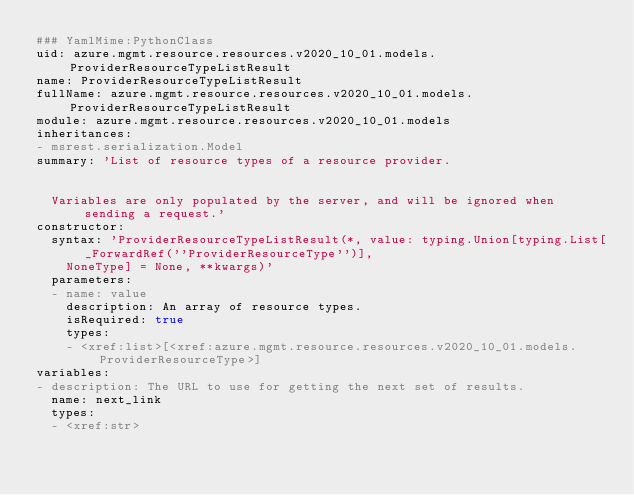<code> <loc_0><loc_0><loc_500><loc_500><_YAML_>### YamlMime:PythonClass
uid: azure.mgmt.resource.resources.v2020_10_01.models.ProviderResourceTypeListResult
name: ProviderResourceTypeListResult
fullName: azure.mgmt.resource.resources.v2020_10_01.models.ProviderResourceTypeListResult
module: azure.mgmt.resource.resources.v2020_10_01.models
inheritances:
- msrest.serialization.Model
summary: 'List of resource types of a resource provider.


  Variables are only populated by the server, and will be ignored when sending a request.'
constructor:
  syntax: 'ProviderResourceTypeListResult(*, value: typing.Union[typing.List[_ForwardRef(''ProviderResourceType'')],
    NoneType] = None, **kwargs)'
  parameters:
  - name: value
    description: An array of resource types.
    isRequired: true
    types:
    - <xref:list>[<xref:azure.mgmt.resource.resources.v2020_10_01.models.ProviderResourceType>]
variables:
- description: The URL to use for getting the next set of results.
  name: next_link
  types:
  - <xref:str>
</code> 